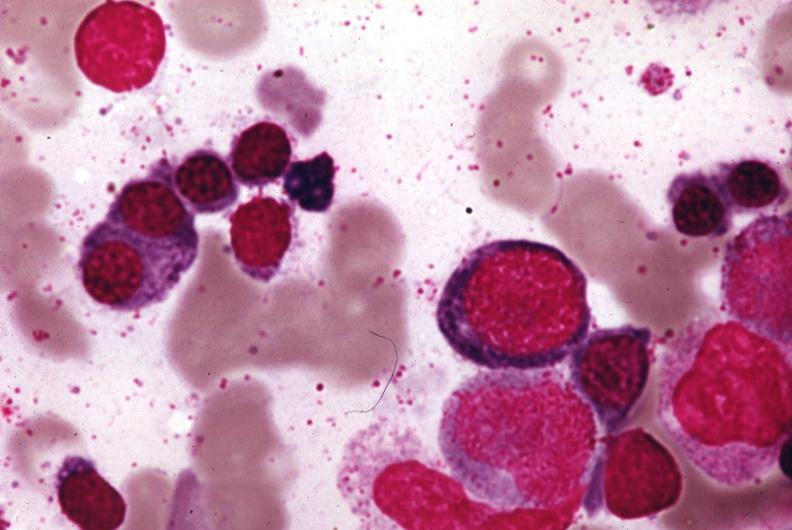what does this image show?
Answer the question using a single word or phrase. Wrights stain 